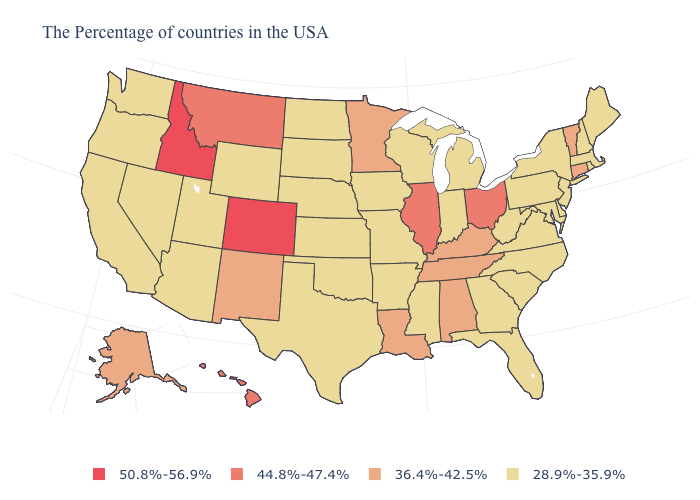Does the first symbol in the legend represent the smallest category?
Concise answer only. No. How many symbols are there in the legend?
Keep it brief. 4. Is the legend a continuous bar?
Answer briefly. No. What is the lowest value in the USA?
Be succinct. 28.9%-35.9%. Does Wyoming have the lowest value in the USA?
Write a very short answer. Yes. Name the states that have a value in the range 50.8%-56.9%?
Quick response, please. Colorado, Idaho. Name the states that have a value in the range 44.8%-47.4%?
Give a very brief answer. Ohio, Illinois, Montana, Hawaii. Does Connecticut have the highest value in the Northeast?
Answer briefly. Yes. Which states have the lowest value in the USA?
Give a very brief answer. Maine, Massachusetts, Rhode Island, New Hampshire, New York, New Jersey, Delaware, Maryland, Pennsylvania, Virginia, North Carolina, South Carolina, West Virginia, Florida, Georgia, Michigan, Indiana, Wisconsin, Mississippi, Missouri, Arkansas, Iowa, Kansas, Nebraska, Oklahoma, Texas, South Dakota, North Dakota, Wyoming, Utah, Arizona, Nevada, California, Washington, Oregon. What is the highest value in states that border Montana?
Give a very brief answer. 50.8%-56.9%. Is the legend a continuous bar?
Be succinct. No. Among the states that border New Mexico , which have the highest value?
Give a very brief answer. Colorado. What is the highest value in the USA?
Short answer required. 50.8%-56.9%. Among the states that border Arizona , does New Mexico have the lowest value?
Short answer required. No. 